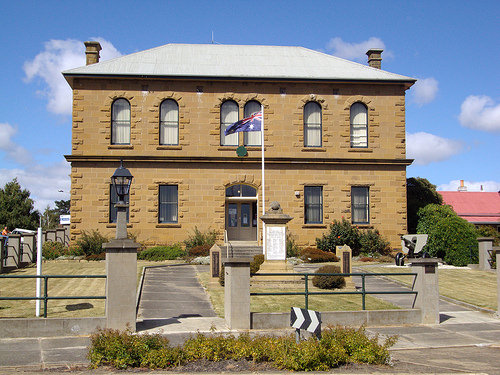<image>
Can you confirm if the light is on the wall? No. The light is not positioned on the wall. They may be near each other, but the light is not supported by or resting on top of the wall. 